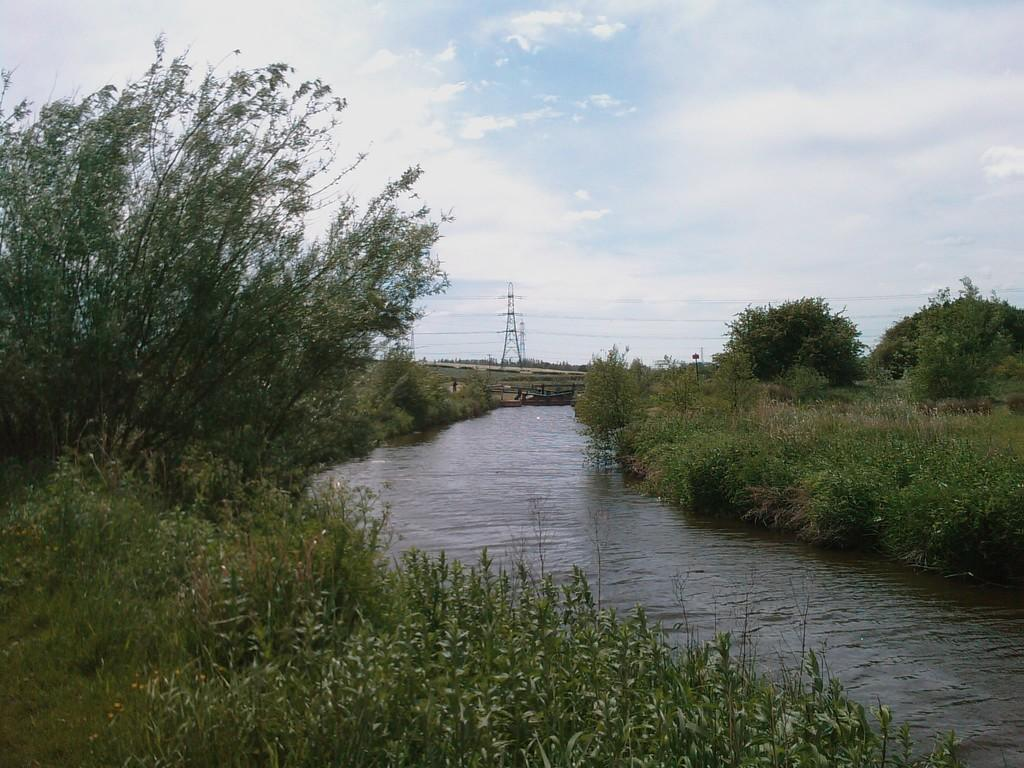What type of vegetation can be seen in the image? There are plants and trees in the image. What type of ground cover is present in the image? There is grass in the image. What can be seen in the water in the image? The facts do not specify what can be seen in the water. What structures are visible in the background of the image? Transmission towers and wires are visible in the background of the image. What part of the natural environment is visible in the image? The sky is visible in the background of the image. What shape is the bone that the leg is resting on in the image? There is no bone or leg present in the image; it features plants, grass, water, trees, transmission towers, wires, and the sky. 